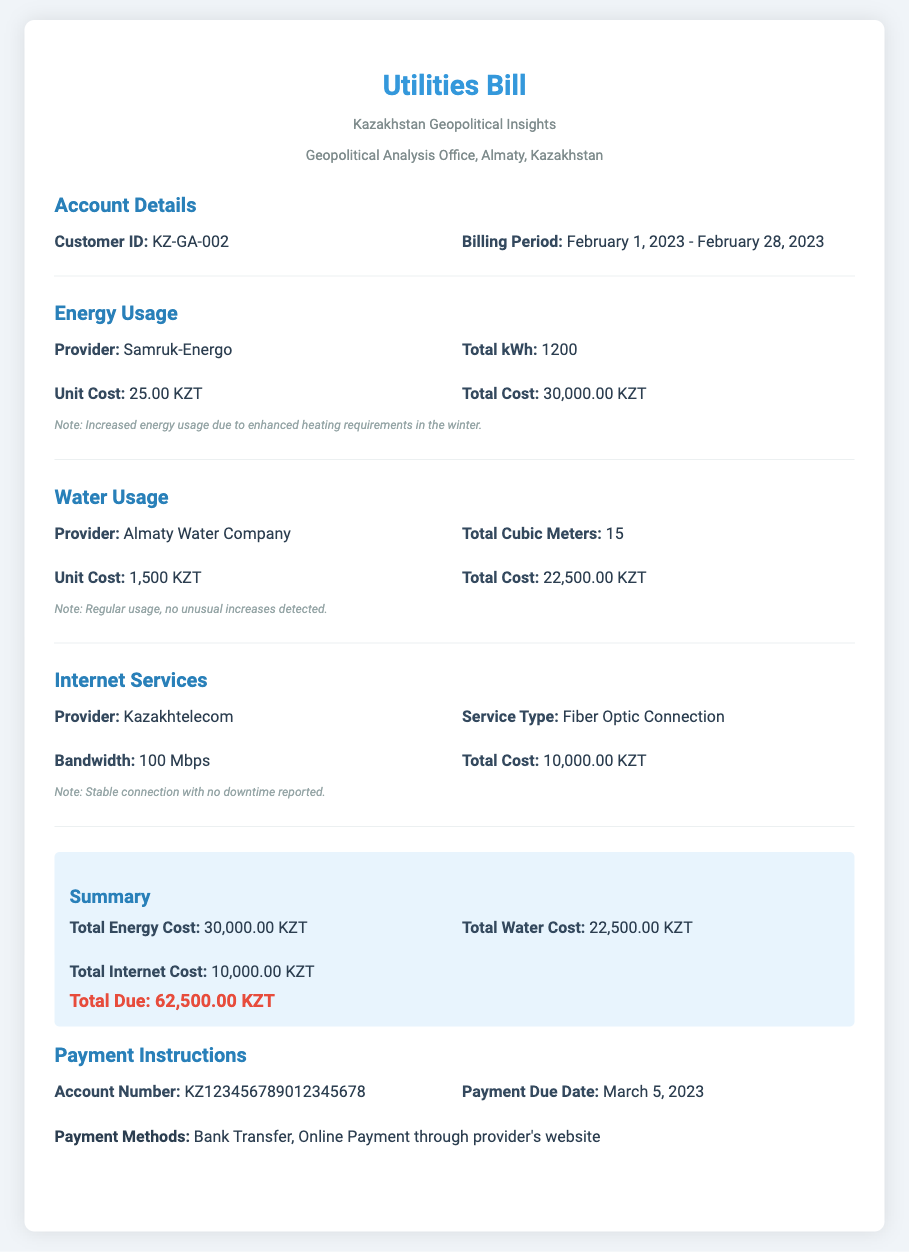What is the Customer ID? The Customer ID is stated in the Account Details section, which is KZ-GA-002.
Answer: KZ-GA-002 What is the billing period? The billing period is mentioned in the Account Details section, which runs from February 1, 2023, to February 28, 2023.
Answer: February 1, 2023 - February 28, 2023 Who is the energy provider? The energy provider is listed in the Energy Usage section, which is Samruk-Energo.
Answer: Samruk-Energo What is the total water cost? The total water cost can be found in the Water Usage section, which states 22,500.00 KZT.
Answer: 22,500.00 KZT What was the total kWh used? The total kWh used is provided in the Energy Usage section, which shows a total of 1200 kWh.
Answer: 1200 What is the bandwidth for the internet service? The bandwidth for the internet service can be found in the Internet Services section, which is 100 Mbps.
Answer: 100 Mbps What payment methods are available? The payment methods are detailed in the Payment Instructions section, mentioning Bank Transfer and Online Payment as options.
Answer: Bank Transfer, Online Payment What is the payment due date? The payment due date is mentioned in the Payment Instructions section as March 5, 2023.
Answer: March 5, 2023 What is the total due amount? The total due amount is outlined in the Summary section as 62,500.00 KZT.
Answer: 62,500.00 KZT 